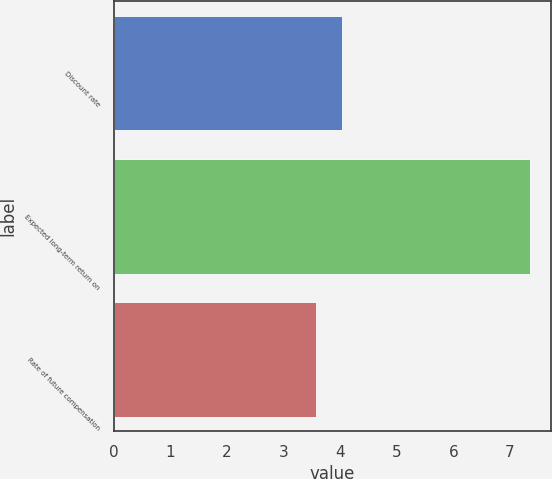Convert chart to OTSL. <chart><loc_0><loc_0><loc_500><loc_500><bar_chart><fcel>Discount rate<fcel>Expected long-term return on<fcel>Rate of future compensation<nl><fcel>4.04<fcel>7.35<fcel>3.58<nl></chart> 